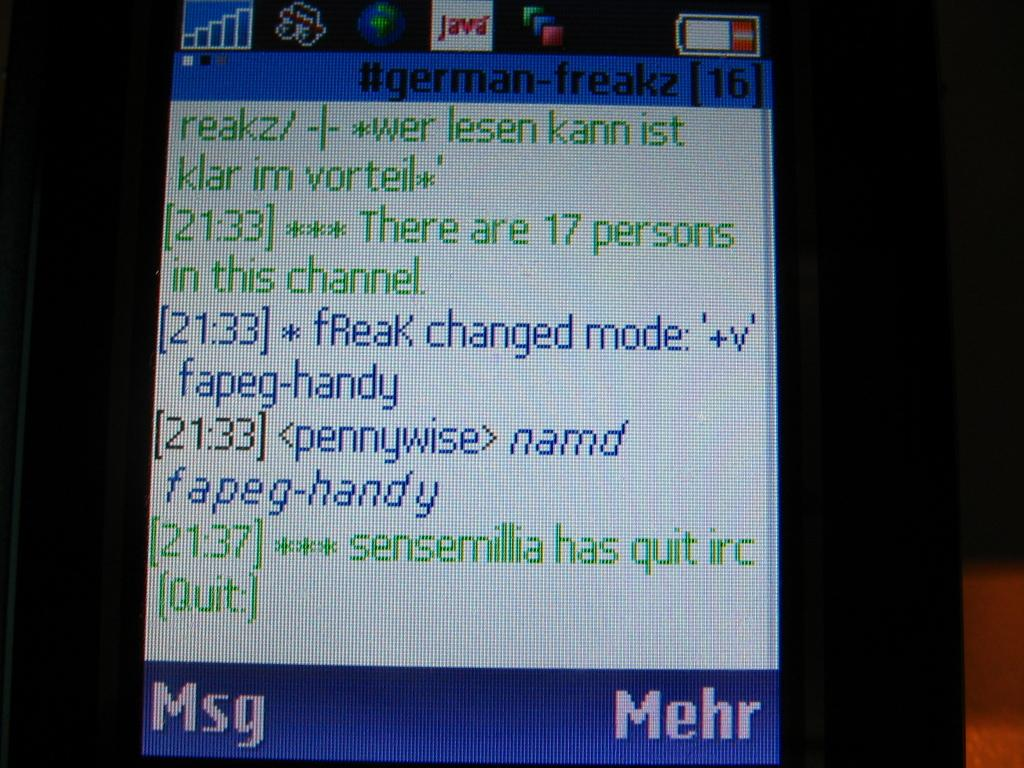<image>
Summarize the visual content of the image. Screen in blue and white showing that 17 people have joined the channel. 